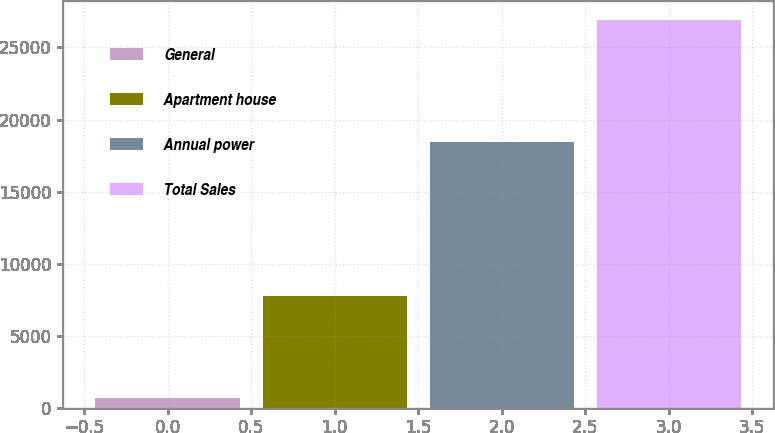Convert chart to OTSL. <chart><loc_0><loc_0><loc_500><loc_500><bar_chart><fcel>General<fcel>Apartment house<fcel>Annual power<fcel>Total Sales<nl><fcel>655<fcel>7748<fcel>18474<fcel>26877<nl></chart> 